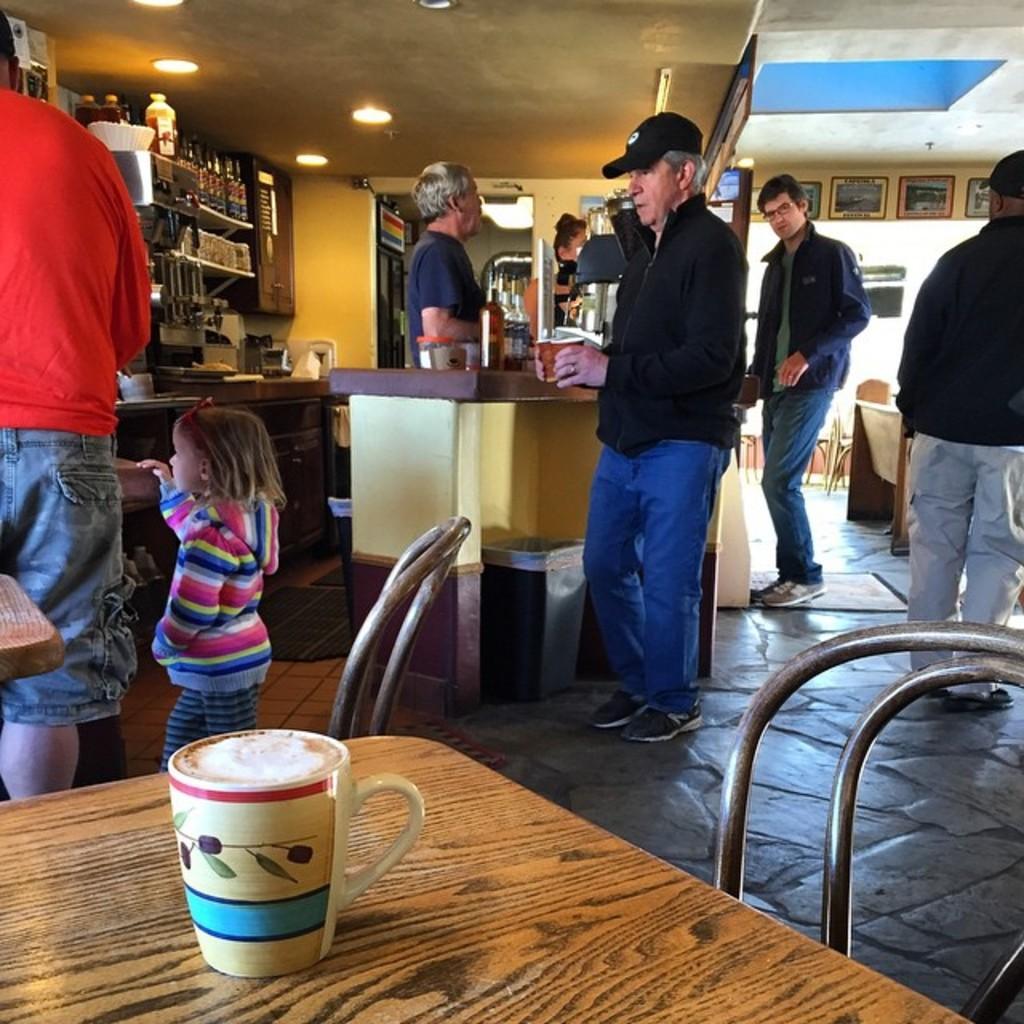Can you describe this image briefly? There are so many people standing few holding a cups and there is a baby girl standing along with the man and there is a coffee cup on the table. 